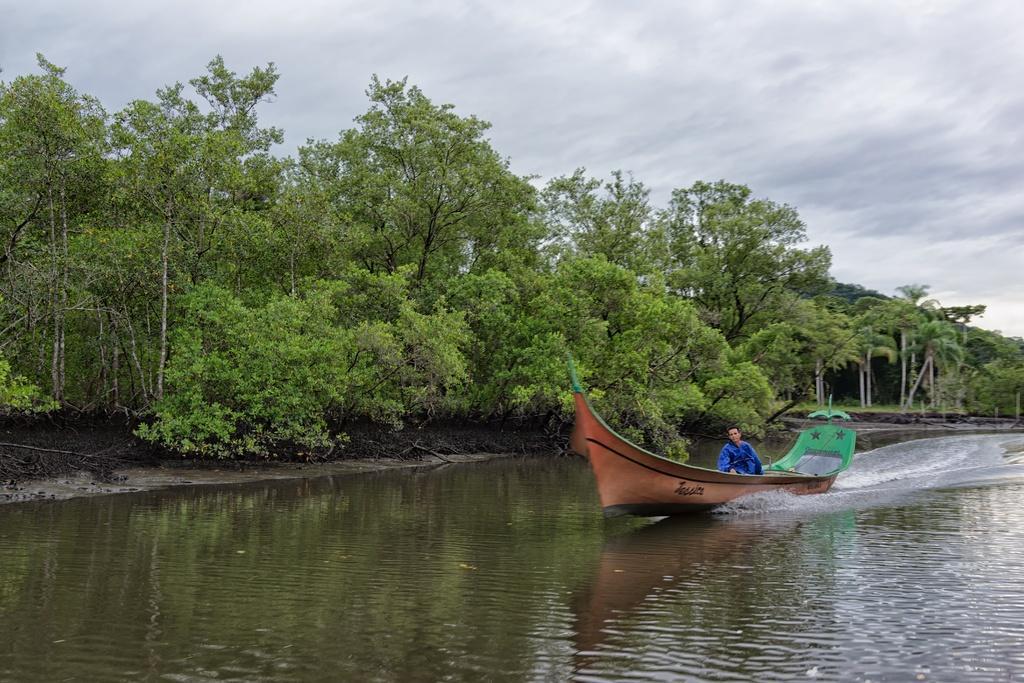How would you summarize this image in a sentence or two? In this image I can see on the right side there is a man in the boat. At the bottom there is water, in the middle there are trees, at the top there is the cloudy sky. 